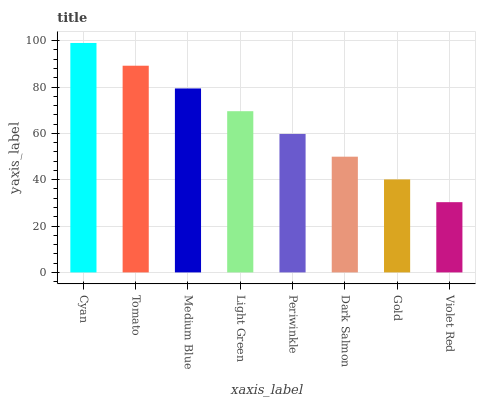Is Violet Red the minimum?
Answer yes or no. Yes. Is Cyan the maximum?
Answer yes or no. Yes. Is Tomato the minimum?
Answer yes or no. No. Is Tomato the maximum?
Answer yes or no. No. Is Cyan greater than Tomato?
Answer yes or no. Yes. Is Tomato less than Cyan?
Answer yes or no. Yes. Is Tomato greater than Cyan?
Answer yes or no. No. Is Cyan less than Tomato?
Answer yes or no. No. Is Light Green the high median?
Answer yes or no. Yes. Is Periwinkle the low median?
Answer yes or no. Yes. Is Tomato the high median?
Answer yes or no. No. Is Gold the low median?
Answer yes or no. No. 